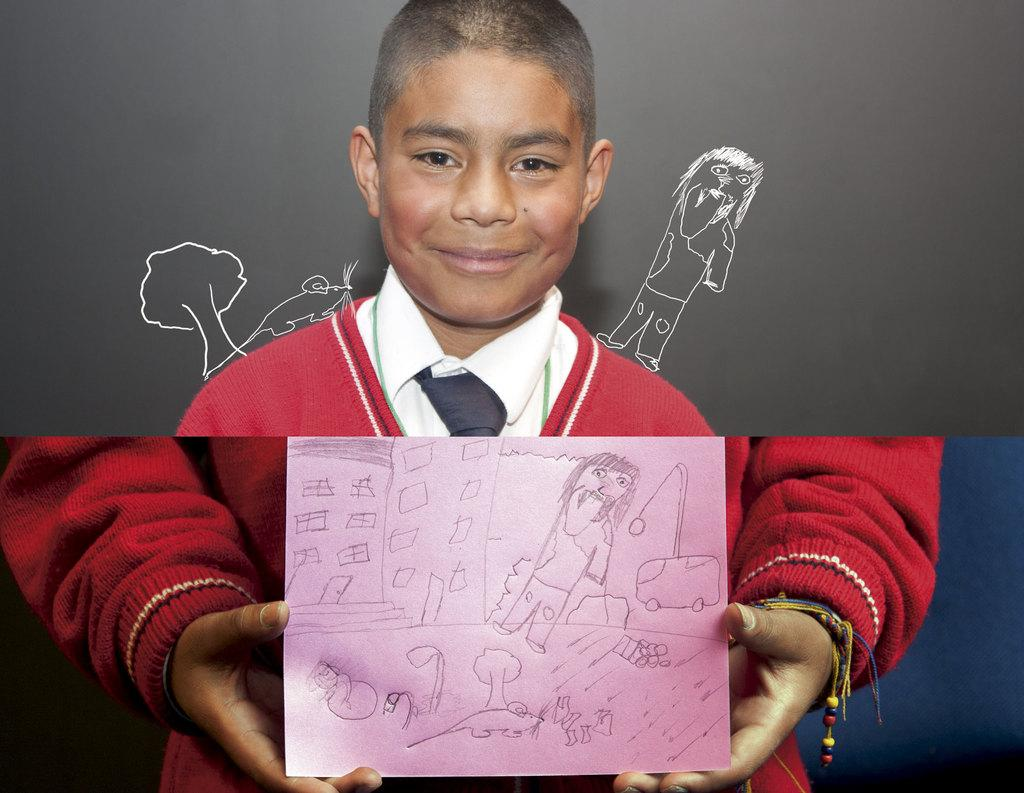What is the person at the bottom of the image doing? The person is standing and holding a paper. What can be seen at the top of the image? There is a poster at the top of the image. What is depicted on the poster? The poster contains an image of a boy. What is the boy in the poster doing? The boy in the poster is standing and smiling. What type of lumber is being used to hold the poster in the image? There is no lumber present in the image; the poster is simply hanging at the top. How is the glue being applied to the note in the image? There is no note or glue present in the image. 